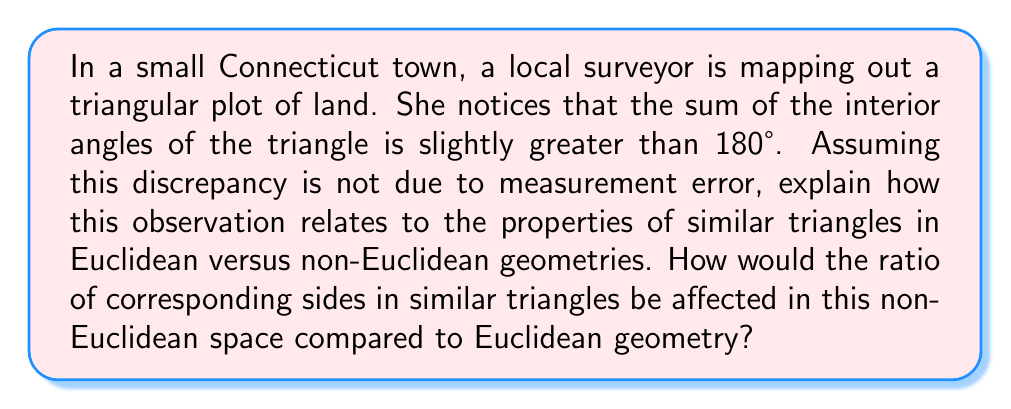Could you help me with this problem? 1. In Euclidean geometry:
   - The sum of interior angles of a triangle is always 180°.
   - Similar triangles have proportional corresponding sides and congruent corresponding angles.
   - The ratio of corresponding sides in similar triangles is constant.

2. The observation of interior angles summing to more than 180° indicates a non-Euclidean geometry, specifically spherical geometry:
   - On a sphere, triangle angles sum to more than 180°.
   - This is due to the positive curvature of the spherical surface.

3. Properties of similar triangles in spherical geometry:
   - Angles are not preserved in similar triangles.
   - The ratio of corresponding sides is not constant.

4. Ratio of corresponding sides in spherical geometry:
   - Let $R$ be the radius of the sphere and $a$, $b$ be the side lengths of two similar triangles.
   - The ratio of corresponding sides is given by:
     $$\frac{\sin(a/R)}{\sin(b/R)} \neq \frac{a}{b}$$

5. Comparison to Euclidean geometry:
   - In Euclidean geometry: $\frac{a}{b} = \text{constant}$ for all corresponding sides.
   - In spherical geometry: $\frac{\sin(a/R)}{\sin(b/R)}$ varies based on the size of the triangle relative to the sphere's radius.

6. Impact on the surveyor's measurements:
   - The ratio of corresponding sides in similar triangles on the Earth's surface (approximated as a sphere) will deviate slightly from the expected Euclidean ratio.
   - This deviation becomes more pronounced for larger triangles relative to the Earth's radius.
Answer: In non-Euclidean (spherical) geometry, the ratio of corresponding sides in similar triangles is not constant, but varies as $\frac{\sin(a/R)}{\sin(b/R)}$, where $R$ is the sphere's radius and $a$, $b$ are side lengths. 